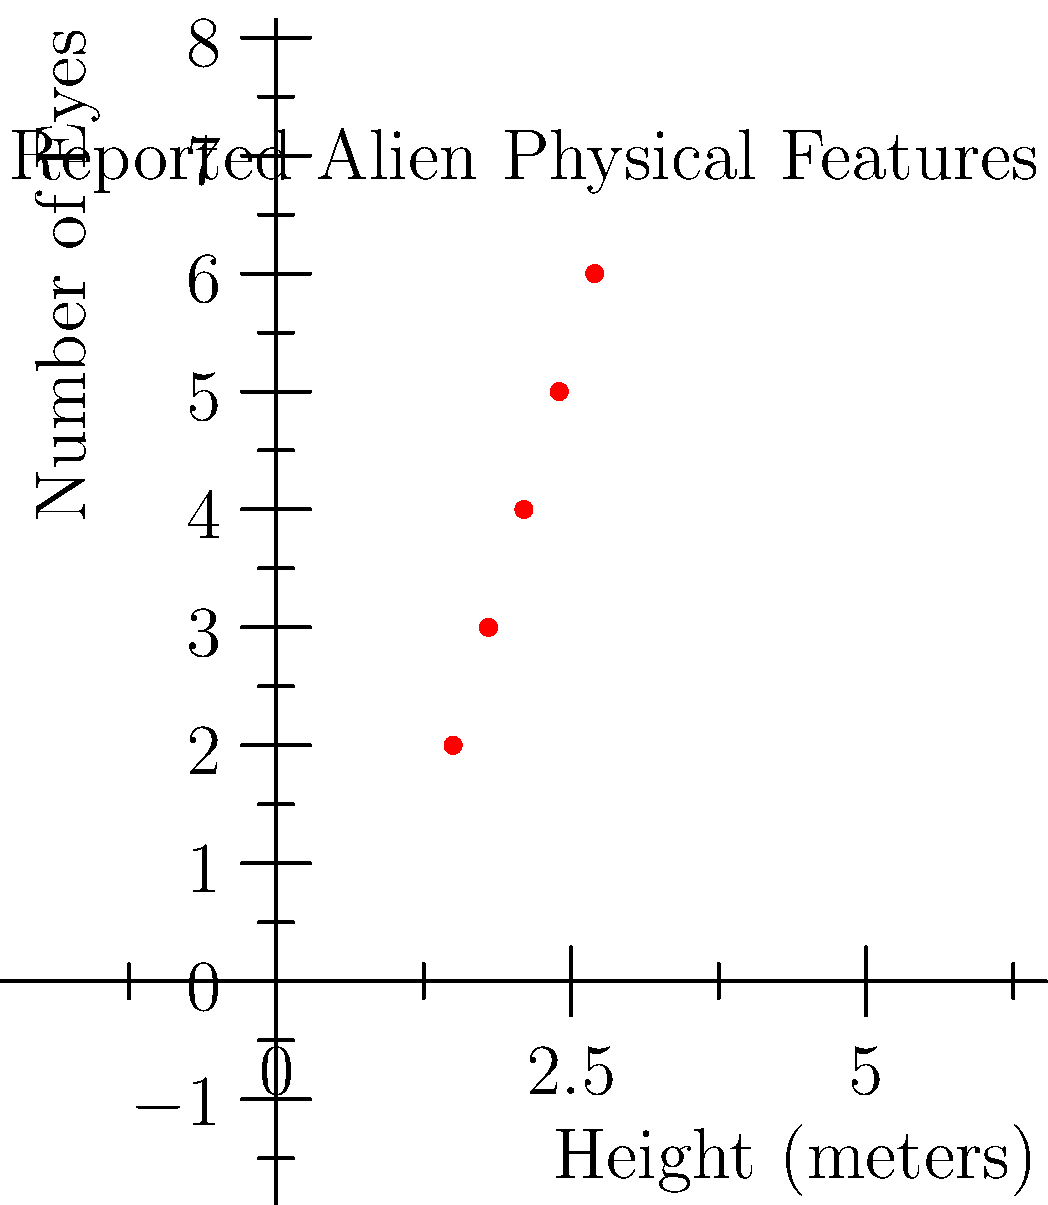Based on the scatter plot of reported alien physical features, what appears to be the relationship between the height of the aliens and the number of eyes they possess? To analyze the relationship between the height of the aliens and the number of eyes they possess, we need to examine the pattern in the scatter plot:

1. Observe the overall trend: As we move from left to right (increasing height), we see that the points generally move upward (increasing number of eyes).

2. Check for linearity: The points seem to follow a roughly straight line, suggesting a linear relationship.

3. Determine the direction: The line slopes upward from left to right, indicating a positive relationship.

4. Assess the strength: The points appear to be closely aligned, suggesting a strong correlation.

5. Look for outliers: There don't appear to be any significant outliers in this data set.

6. Quantify the relationship: We can estimate that for every 0.3 meters increase in height, there is approximately a 1 unit increase in the number of eyes.

Given these observations, we can conclude that there appears to be a strong positive linear relationship between the height of the reported aliens and the number of eyes they possess.
Answer: Strong positive linear relationship 